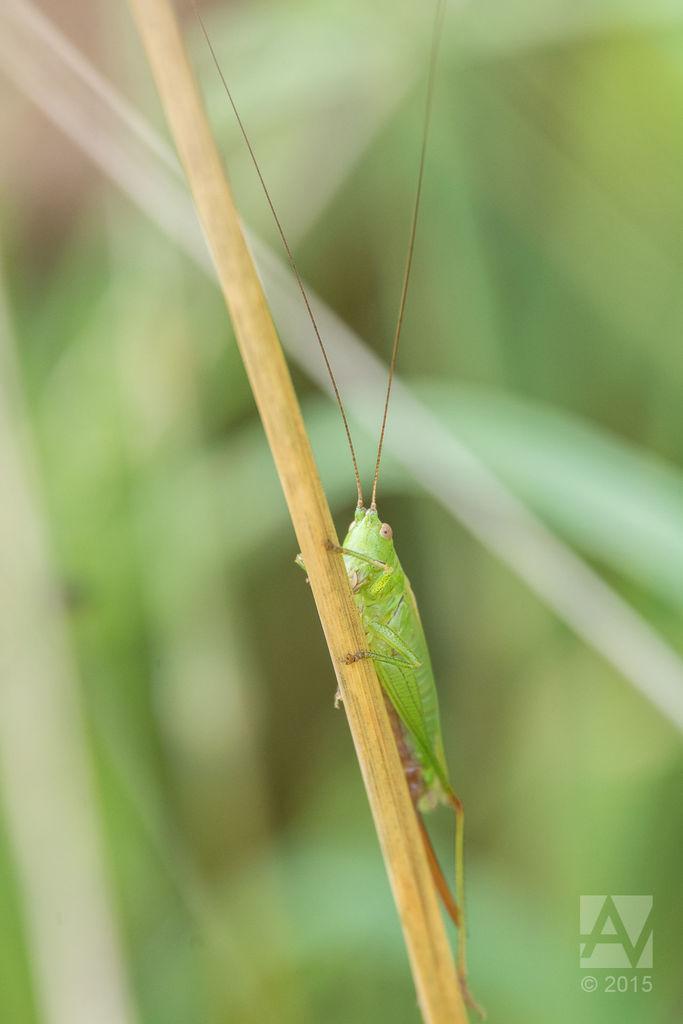How would you summarize this image in a sentence or two? In this image there is a grasshopper on the branch , and there is a watermark on the image. 